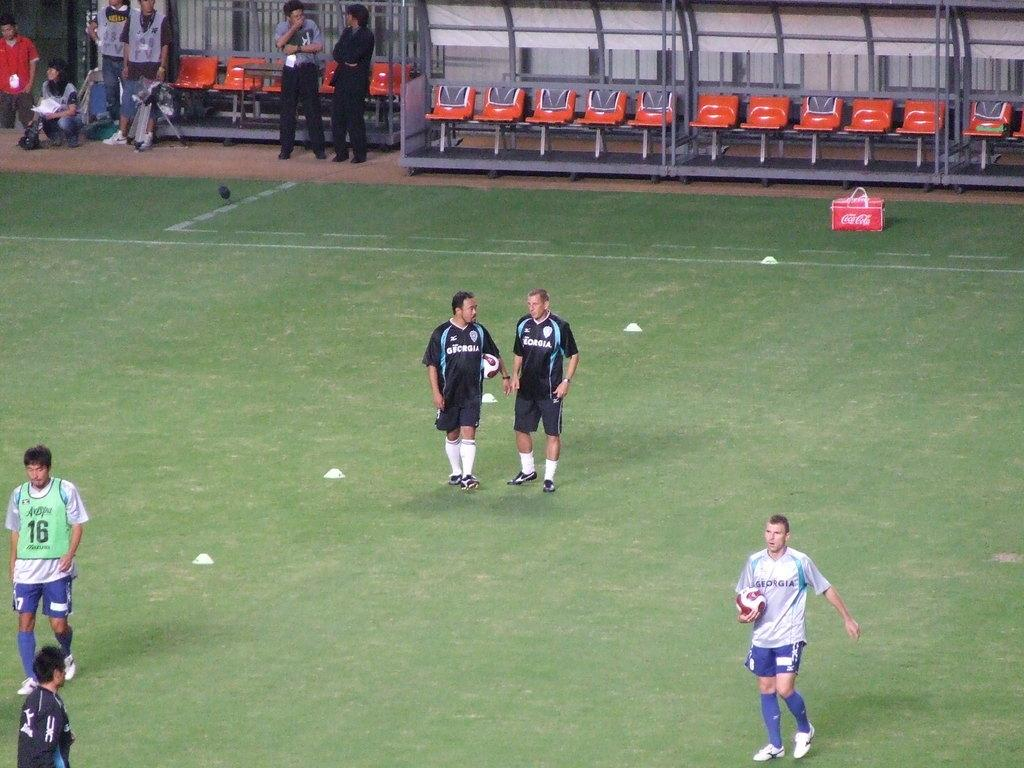<image>
Create a compact narrative representing the image presented. soccer players on a field with Georgia displayed on their jerseys 